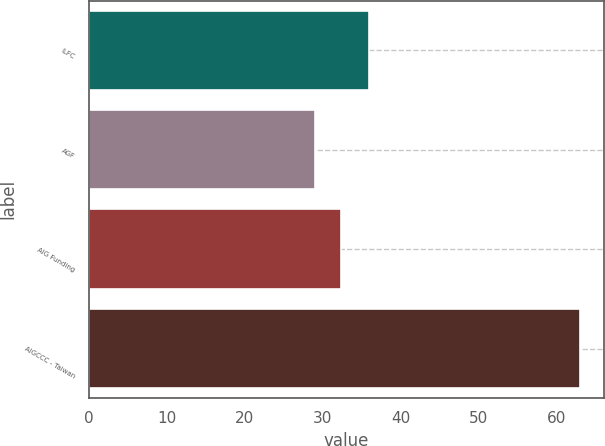Convert chart to OTSL. <chart><loc_0><loc_0><loc_500><loc_500><bar_chart><fcel>ILFC<fcel>AGF<fcel>AIG Funding<fcel>AIGCCC - Taiwan<nl><fcel>36<fcel>29<fcel>32.4<fcel>63<nl></chart> 